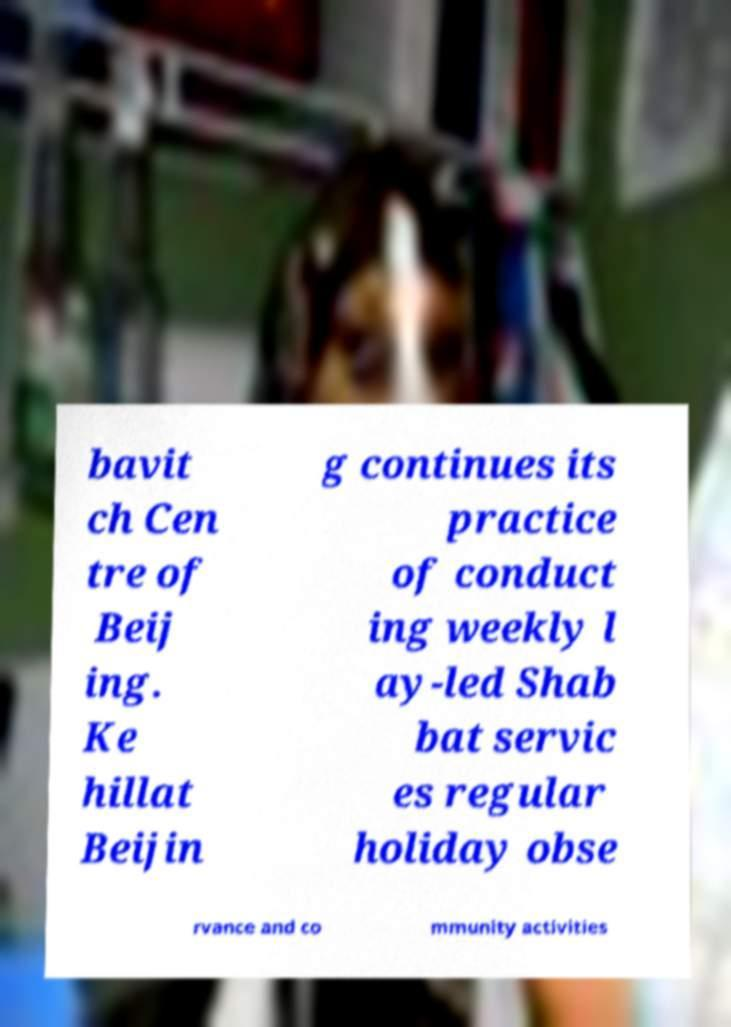Could you extract and type out the text from this image? bavit ch Cen tre of Beij ing. Ke hillat Beijin g continues its practice of conduct ing weekly l ay-led Shab bat servic es regular holiday obse rvance and co mmunity activities 